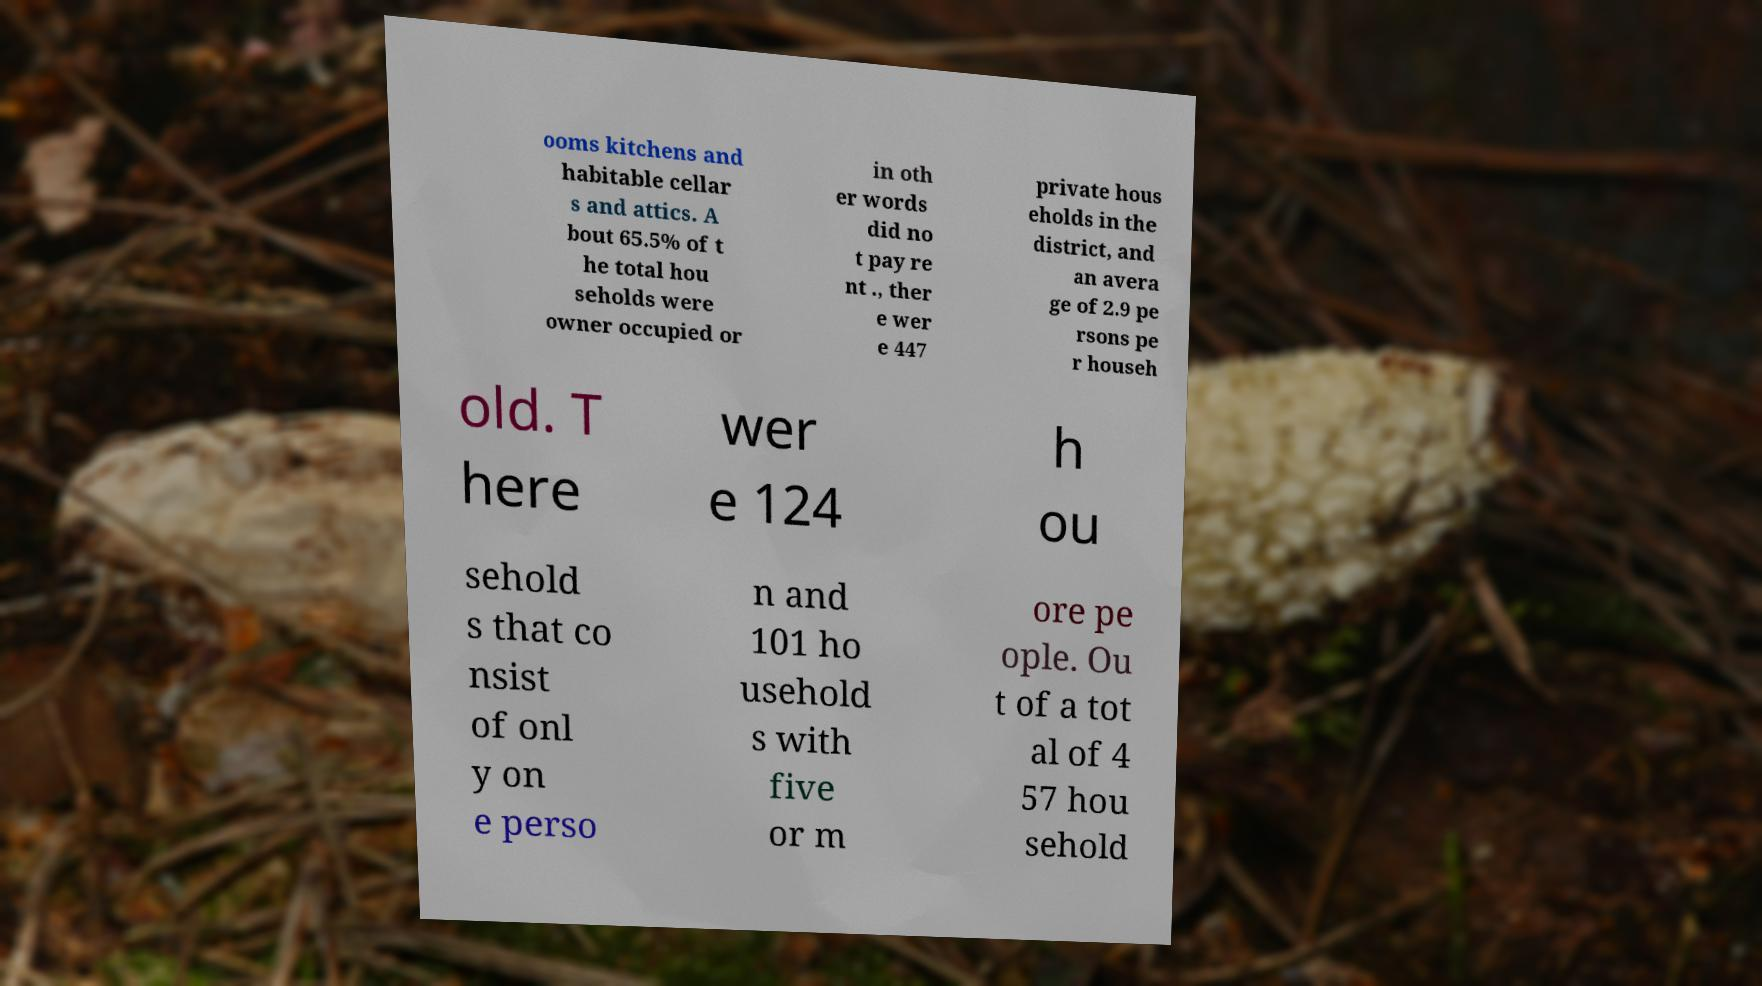I need the written content from this picture converted into text. Can you do that? ooms kitchens and habitable cellar s and attics. A bout 65.5% of t he total hou seholds were owner occupied or in oth er words did no t pay re nt ., ther e wer e 447 private hous eholds in the district, and an avera ge of 2.9 pe rsons pe r househ old. T here wer e 124 h ou sehold s that co nsist of onl y on e perso n and 101 ho usehold s with five or m ore pe ople. Ou t of a tot al of 4 57 hou sehold 